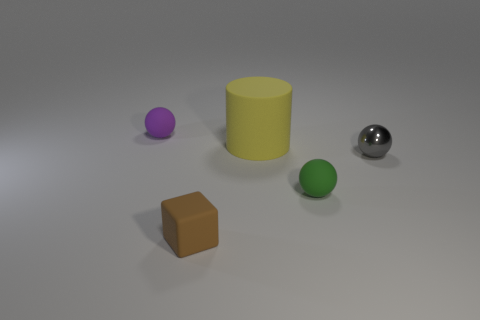Is there any other thing that has the same size as the yellow rubber cylinder?
Ensure brevity in your answer.  No. What is the material of the object that is in front of the gray shiny sphere and on the right side of the yellow rubber object?
Offer a very short reply. Rubber. Is there a matte ball of the same size as the shiny sphere?
Your answer should be very brief. Yes. What number of tiny blue shiny balls are there?
Provide a short and direct response. 0. How many small rubber spheres are in front of the metallic ball?
Give a very brief answer. 1. Is the material of the small green thing the same as the brown thing?
Keep it short and to the point. Yes. How many objects are both in front of the yellow cylinder and to the right of the small brown cube?
Offer a very short reply. 2. What number of brown things are tiny cubes or metal things?
Make the answer very short. 1. The cylinder is what size?
Offer a terse response. Large. What number of metal things are either small spheres or cylinders?
Provide a short and direct response. 1. 